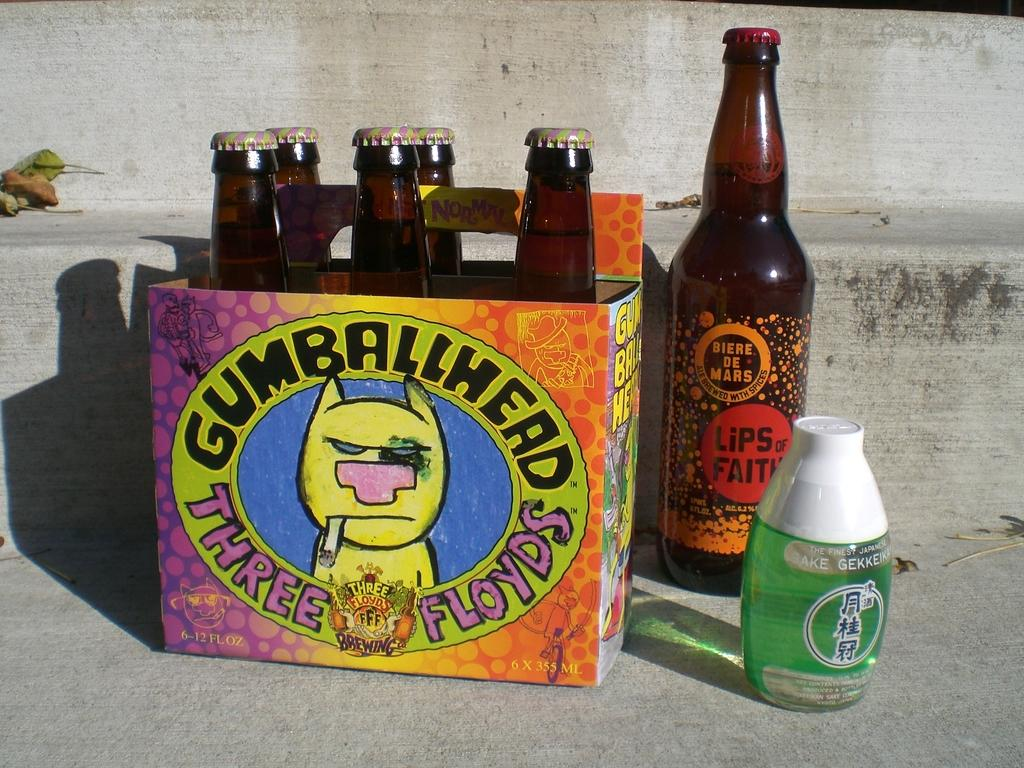Provide a one-sentence caption for the provided image. Case of Gumballhead Three Floyds beer outdoors on a step. 